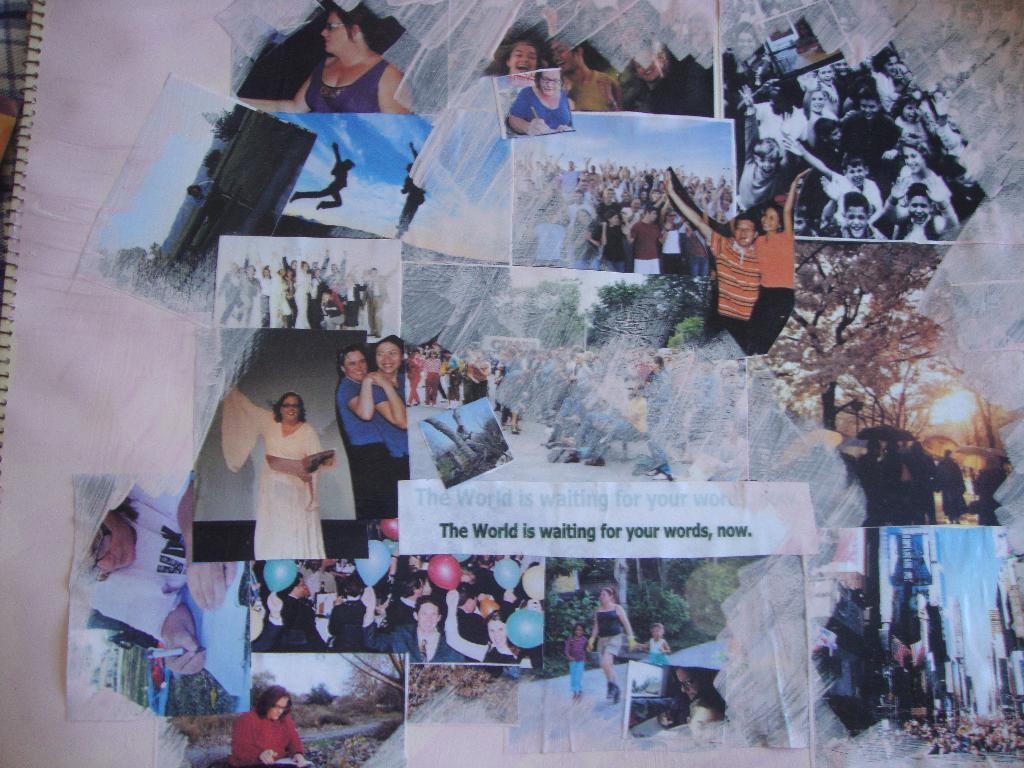<image>
Give a short and clear explanation of the subsequent image. a page with pictures on it that says 'the world is waiting for your words, now.' 